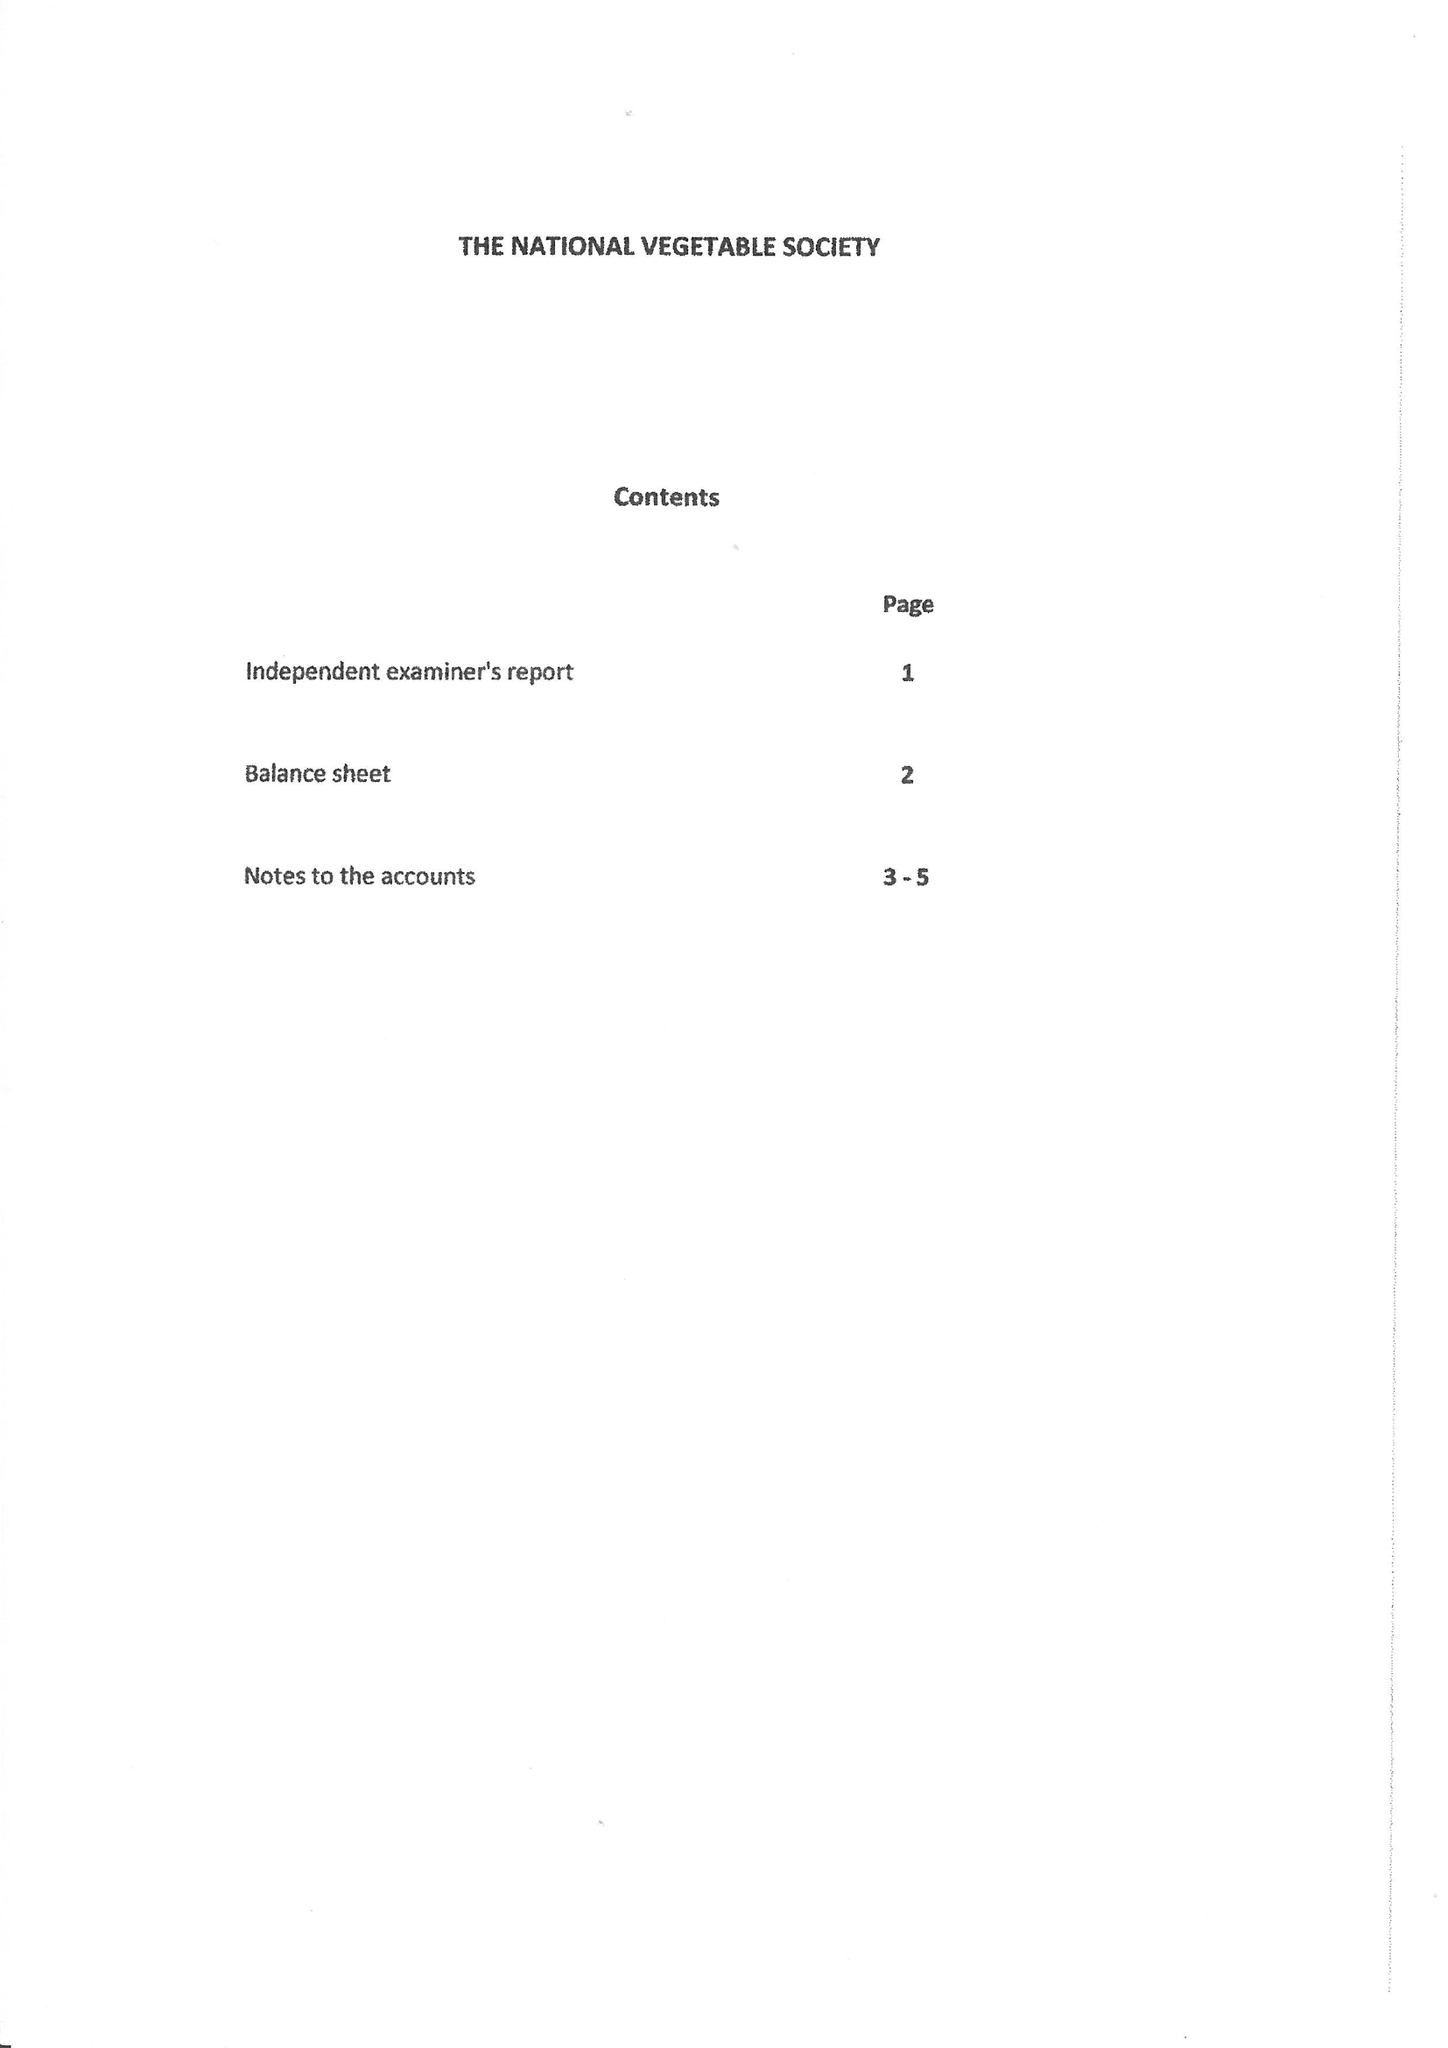What is the value for the charity_name?
Answer the question using a single word or phrase. The National Vegetable Society 